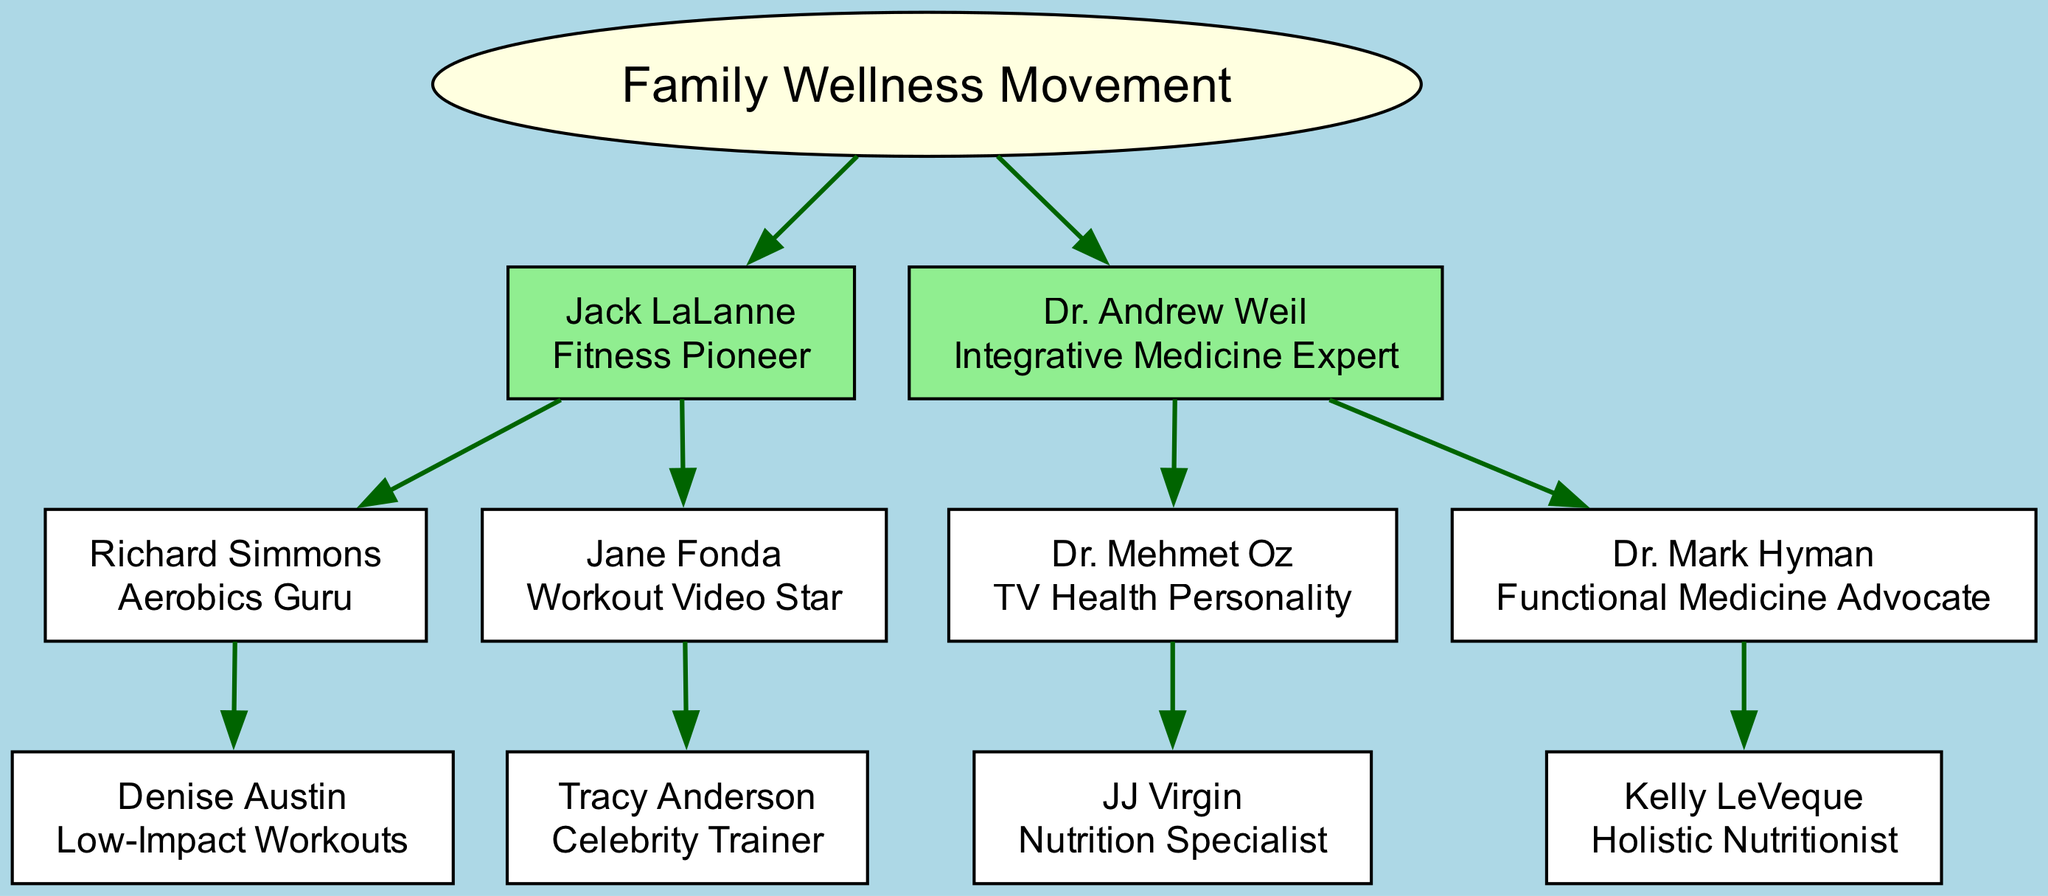What is the title of Jack LaLanne? The title given to Jack LaLanne in the diagram is "Fitness Pioneer," which is specified directly under his name in the node.
Answer: Fitness Pioneer How many children does Dr. Andrew Weil have? In the diagram, Dr. Andrew Weil has two direct children: Dr. Mehmet Oz and Dr. Mark Hyman, as indicated by the branches stemming from his node.
Answer: 2 What is the relationship between Richard Simmons and Denise Austin? Richard Simmons is a child of Jack LaLanne and has one child, Denise Austin, making Denise Austin the grandchild of Jack LaLanne. This relationship is established as Denise Austin branches from Richard Simmons.
Answer: Grandchild Who is the celebrity trainer under Jane Fonda? The diagram clearly shows that under Jane Fonda, the celebrity trainer listed is Tracy Anderson, indicating her positioning directly beneath Jane Fonda as a child node.
Answer: Tracy Anderson What is the highest level of education or expertise represented in this genealogy? The individuals listed as the root and branches embody various expertise levels, with Dr. Andrew Weil, Dr. Mehmet Oz, and Dr. Mark Hyman having titles reflecting advanced knowledge in medicine and health, which showcases the diagram's hierarchical knowledge level.
Answer: Integrative Medicine Expert Which expert is known for low-impact workouts? The diagram identifies Denise Austin as the expert known for low-impact workouts, which is specified right beneath her name in the node.
Answer: Denise Austin What type of medicine does Dr. Mark Hyman advocate for? The diagram shows Dr. Mark Hyman advocating for "Functional Medicine," which is explicitly mentioned in his title as part of the node description.
Answer: Functional Medicine How many generations are represented in the family wellness movement tree? The diagram displays three generations: the root (Family Wellness Movement), then the first generation (Jack LaLanne and Dr. Andrew Weil), followed by their respective children, illustrating a total of three levels of ancestry in the tree.
Answer: 3 What health-related profession does JJ Virgin represent? JJ Virgin is represented in the diagram with the title "Nutrition Specialist," which specifies her health-related profession directly under her name.
Answer: Nutrition Specialist 